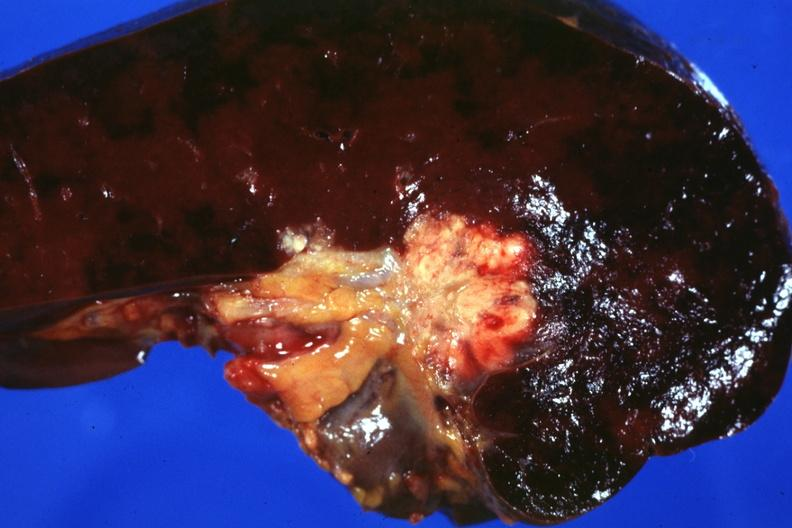s leg present?
Answer the question using a single word or phrase. No 